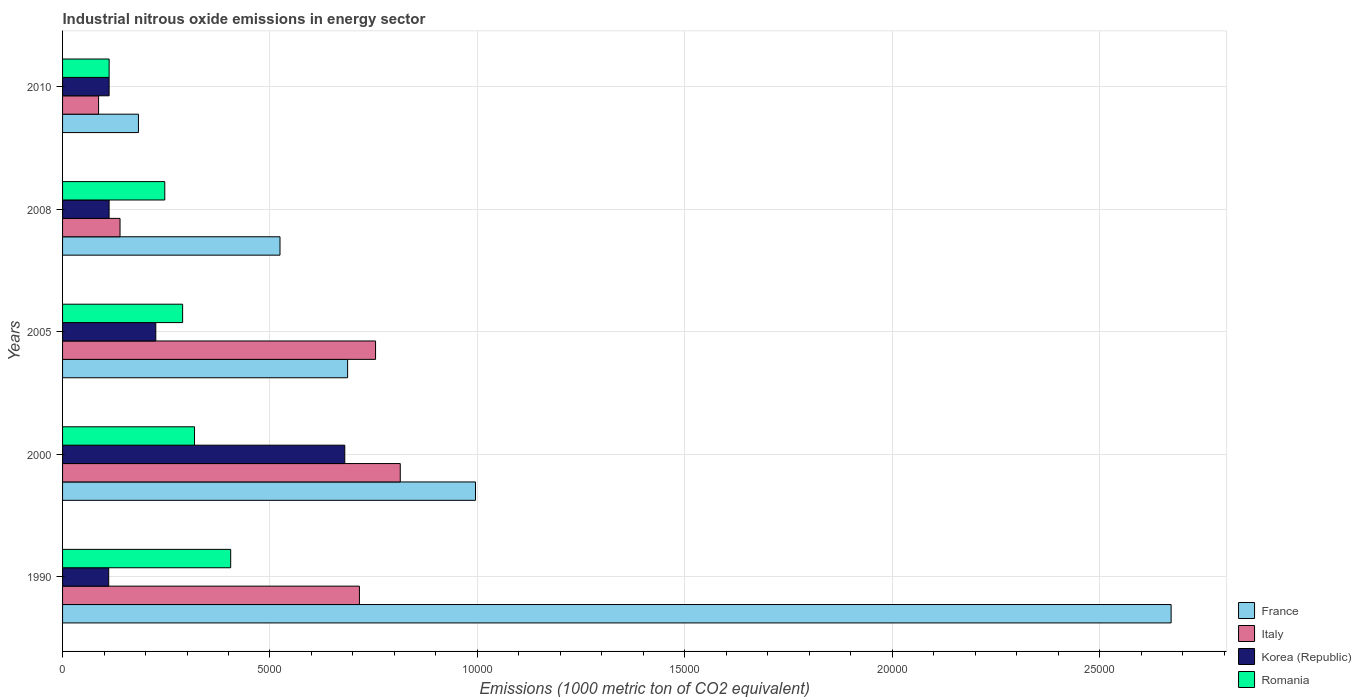How many different coloured bars are there?
Give a very brief answer. 4. Are the number of bars on each tick of the Y-axis equal?
Offer a terse response. Yes. What is the label of the 3rd group of bars from the top?
Your answer should be compact. 2005. What is the amount of industrial nitrous oxide emitted in Romania in 2005?
Provide a short and direct response. 2894.1. Across all years, what is the maximum amount of industrial nitrous oxide emitted in Romania?
Make the answer very short. 4052.7. Across all years, what is the minimum amount of industrial nitrous oxide emitted in Korea (Republic)?
Make the answer very short. 1112.3. In which year was the amount of industrial nitrous oxide emitted in France maximum?
Give a very brief answer. 1990. In which year was the amount of industrial nitrous oxide emitted in Romania minimum?
Your answer should be compact. 2010. What is the total amount of industrial nitrous oxide emitted in Romania in the graph?
Ensure brevity in your answer.  1.37e+04. What is the difference between the amount of industrial nitrous oxide emitted in France in 2005 and that in 2010?
Provide a succinct answer. 5042.8. What is the difference between the amount of industrial nitrous oxide emitted in Romania in 2010 and the amount of industrial nitrous oxide emitted in Italy in 2005?
Ensure brevity in your answer.  -6422.6. What is the average amount of industrial nitrous oxide emitted in France per year?
Provide a short and direct response. 1.01e+04. In the year 2010, what is the difference between the amount of industrial nitrous oxide emitted in Korea (Republic) and amount of industrial nitrous oxide emitted in France?
Offer a very short reply. -706.3. What is the ratio of the amount of industrial nitrous oxide emitted in Italy in 2000 to that in 2010?
Provide a short and direct response. 9.38. What is the difference between the highest and the second highest amount of industrial nitrous oxide emitted in Korea (Republic)?
Keep it short and to the point. 4555.5. What is the difference between the highest and the lowest amount of industrial nitrous oxide emitted in Korea (Republic)?
Ensure brevity in your answer.  5690.7. In how many years, is the amount of industrial nitrous oxide emitted in Italy greater than the average amount of industrial nitrous oxide emitted in Italy taken over all years?
Your answer should be compact. 3. Is it the case that in every year, the sum of the amount of industrial nitrous oxide emitted in Italy and amount of industrial nitrous oxide emitted in France is greater than the amount of industrial nitrous oxide emitted in Romania?
Provide a succinct answer. Yes. How many bars are there?
Give a very brief answer. 20. Are all the bars in the graph horizontal?
Make the answer very short. Yes. Does the graph contain any zero values?
Offer a terse response. No. Does the graph contain grids?
Provide a succinct answer. Yes. How are the legend labels stacked?
Your answer should be very brief. Vertical. What is the title of the graph?
Ensure brevity in your answer.  Industrial nitrous oxide emissions in energy sector. Does "Luxembourg" appear as one of the legend labels in the graph?
Make the answer very short. No. What is the label or title of the X-axis?
Keep it short and to the point. Emissions (1000 metric ton of CO2 equivalent). What is the Emissions (1000 metric ton of CO2 equivalent) in France in 1990?
Your answer should be compact. 2.67e+04. What is the Emissions (1000 metric ton of CO2 equivalent) in Italy in 1990?
Make the answer very short. 7155.8. What is the Emissions (1000 metric ton of CO2 equivalent) in Korea (Republic) in 1990?
Offer a very short reply. 1112.3. What is the Emissions (1000 metric ton of CO2 equivalent) of Romania in 1990?
Your answer should be very brief. 4052.7. What is the Emissions (1000 metric ton of CO2 equivalent) in France in 2000?
Offer a very short reply. 9953.8. What is the Emissions (1000 metric ton of CO2 equivalent) of Italy in 2000?
Keep it short and to the point. 8140.4. What is the Emissions (1000 metric ton of CO2 equivalent) in Korea (Republic) in 2000?
Keep it short and to the point. 6803. What is the Emissions (1000 metric ton of CO2 equivalent) in Romania in 2000?
Provide a short and direct response. 3180.9. What is the Emissions (1000 metric ton of CO2 equivalent) of France in 2005?
Your answer should be compact. 6871.6. What is the Emissions (1000 metric ton of CO2 equivalent) in Italy in 2005?
Keep it short and to the point. 7544.9. What is the Emissions (1000 metric ton of CO2 equivalent) in Korea (Republic) in 2005?
Provide a succinct answer. 2247.5. What is the Emissions (1000 metric ton of CO2 equivalent) in Romania in 2005?
Provide a succinct answer. 2894.1. What is the Emissions (1000 metric ton of CO2 equivalent) in France in 2008?
Make the answer very short. 5241.3. What is the Emissions (1000 metric ton of CO2 equivalent) of Italy in 2008?
Ensure brevity in your answer.  1385.2. What is the Emissions (1000 metric ton of CO2 equivalent) of Korea (Republic) in 2008?
Make the answer very short. 1121.9. What is the Emissions (1000 metric ton of CO2 equivalent) in Romania in 2008?
Your answer should be compact. 2463.8. What is the Emissions (1000 metric ton of CO2 equivalent) of France in 2010?
Keep it short and to the point. 1828.8. What is the Emissions (1000 metric ton of CO2 equivalent) in Italy in 2010?
Your answer should be compact. 868. What is the Emissions (1000 metric ton of CO2 equivalent) in Korea (Republic) in 2010?
Offer a terse response. 1122.5. What is the Emissions (1000 metric ton of CO2 equivalent) in Romania in 2010?
Offer a very short reply. 1122.3. Across all years, what is the maximum Emissions (1000 metric ton of CO2 equivalent) in France?
Make the answer very short. 2.67e+04. Across all years, what is the maximum Emissions (1000 metric ton of CO2 equivalent) in Italy?
Provide a succinct answer. 8140.4. Across all years, what is the maximum Emissions (1000 metric ton of CO2 equivalent) in Korea (Republic)?
Ensure brevity in your answer.  6803. Across all years, what is the maximum Emissions (1000 metric ton of CO2 equivalent) in Romania?
Offer a very short reply. 4052.7. Across all years, what is the minimum Emissions (1000 metric ton of CO2 equivalent) of France?
Make the answer very short. 1828.8. Across all years, what is the minimum Emissions (1000 metric ton of CO2 equivalent) of Italy?
Keep it short and to the point. 868. Across all years, what is the minimum Emissions (1000 metric ton of CO2 equivalent) of Korea (Republic)?
Ensure brevity in your answer.  1112.3. Across all years, what is the minimum Emissions (1000 metric ton of CO2 equivalent) in Romania?
Make the answer very short. 1122.3. What is the total Emissions (1000 metric ton of CO2 equivalent) of France in the graph?
Provide a short and direct response. 5.06e+04. What is the total Emissions (1000 metric ton of CO2 equivalent) of Italy in the graph?
Offer a very short reply. 2.51e+04. What is the total Emissions (1000 metric ton of CO2 equivalent) of Korea (Republic) in the graph?
Provide a short and direct response. 1.24e+04. What is the total Emissions (1000 metric ton of CO2 equivalent) of Romania in the graph?
Keep it short and to the point. 1.37e+04. What is the difference between the Emissions (1000 metric ton of CO2 equivalent) of France in 1990 and that in 2000?
Offer a very short reply. 1.68e+04. What is the difference between the Emissions (1000 metric ton of CO2 equivalent) in Italy in 1990 and that in 2000?
Keep it short and to the point. -984.6. What is the difference between the Emissions (1000 metric ton of CO2 equivalent) in Korea (Republic) in 1990 and that in 2000?
Provide a succinct answer. -5690.7. What is the difference between the Emissions (1000 metric ton of CO2 equivalent) of Romania in 1990 and that in 2000?
Keep it short and to the point. 871.8. What is the difference between the Emissions (1000 metric ton of CO2 equivalent) in France in 1990 and that in 2005?
Ensure brevity in your answer.  1.99e+04. What is the difference between the Emissions (1000 metric ton of CO2 equivalent) of Italy in 1990 and that in 2005?
Offer a very short reply. -389.1. What is the difference between the Emissions (1000 metric ton of CO2 equivalent) in Korea (Republic) in 1990 and that in 2005?
Keep it short and to the point. -1135.2. What is the difference between the Emissions (1000 metric ton of CO2 equivalent) in Romania in 1990 and that in 2005?
Make the answer very short. 1158.6. What is the difference between the Emissions (1000 metric ton of CO2 equivalent) in France in 1990 and that in 2008?
Give a very brief answer. 2.15e+04. What is the difference between the Emissions (1000 metric ton of CO2 equivalent) in Italy in 1990 and that in 2008?
Provide a short and direct response. 5770.6. What is the difference between the Emissions (1000 metric ton of CO2 equivalent) in Romania in 1990 and that in 2008?
Offer a terse response. 1588.9. What is the difference between the Emissions (1000 metric ton of CO2 equivalent) of France in 1990 and that in 2010?
Give a very brief answer. 2.49e+04. What is the difference between the Emissions (1000 metric ton of CO2 equivalent) of Italy in 1990 and that in 2010?
Your answer should be compact. 6287.8. What is the difference between the Emissions (1000 metric ton of CO2 equivalent) in Korea (Republic) in 1990 and that in 2010?
Your answer should be compact. -10.2. What is the difference between the Emissions (1000 metric ton of CO2 equivalent) of Romania in 1990 and that in 2010?
Your answer should be compact. 2930.4. What is the difference between the Emissions (1000 metric ton of CO2 equivalent) in France in 2000 and that in 2005?
Provide a succinct answer. 3082.2. What is the difference between the Emissions (1000 metric ton of CO2 equivalent) in Italy in 2000 and that in 2005?
Your response must be concise. 595.5. What is the difference between the Emissions (1000 metric ton of CO2 equivalent) in Korea (Republic) in 2000 and that in 2005?
Your response must be concise. 4555.5. What is the difference between the Emissions (1000 metric ton of CO2 equivalent) in Romania in 2000 and that in 2005?
Provide a short and direct response. 286.8. What is the difference between the Emissions (1000 metric ton of CO2 equivalent) in France in 2000 and that in 2008?
Give a very brief answer. 4712.5. What is the difference between the Emissions (1000 metric ton of CO2 equivalent) in Italy in 2000 and that in 2008?
Keep it short and to the point. 6755.2. What is the difference between the Emissions (1000 metric ton of CO2 equivalent) of Korea (Republic) in 2000 and that in 2008?
Your answer should be compact. 5681.1. What is the difference between the Emissions (1000 metric ton of CO2 equivalent) in Romania in 2000 and that in 2008?
Offer a very short reply. 717.1. What is the difference between the Emissions (1000 metric ton of CO2 equivalent) of France in 2000 and that in 2010?
Make the answer very short. 8125. What is the difference between the Emissions (1000 metric ton of CO2 equivalent) of Italy in 2000 and that in 2010?
Your response must be concise. 7272.4. What is the difference between the Emissions (1000 metric ton of CO2 equivalent) of Korea (Republic) in 2000 and that in 2010?
Ensure brevity in your answer.  5680.5. What is the difference between the Emissions (1000 metric ton of CO2 equivalent) in Romania in 2000 and that in 2010?
Provide a short and direct response. 2058.6. What is the difference between the Emissions (1000 metric ton of CO2 equivalent) in France in 2005 and that in 2008?
Provide a succinct answer. 1630.3. What is the difference between the Emissions (1000 metric ton of CO2 equivalent) in Italy in 2005 and that in 2008?
Offer a terse response. 6159.7. What is the difference between the Emissions (1000 metric ton of CO2 equivalent) in Korea (Republic) in 2005 and that in 2008?
Make the answer very short. 1125.6. What is the difference between the Emissions (1000 metric ton of CO2 equivalent) of Romania in 2005 and that in 2008?
Keep it short and to the point. 430.3. What is the difference between the Emissions (1000 metric ton of CO2 equivalent) of France in 2005 and that in 2010?
Provide a short and direct response. 5042.8. What is the difference between the Emissions (1000 metric ton of CO2 equivalent) of Italy in 2005 and that in 2010?
Keep it short and to the point. 6676.9. What is the difference between the Emissions (1000 metric ton of CO2 equivalent) in Korea (Republic) in 2005 and that in 2010?
Give a very brief answer. 1125. What is the difference between the Emissions (1000 metric ton of CO2 equivalent) in Romania in 2005 and that in 2010?
Your response must be concise. 1771.8. What is the difference between the Emissions (1000 metric ton of CO2 equivalent) of France in 2008 and that in 2010?
Give a very brief answer. 3412.5. What is the difference between the Emissions (1000 metric ton of CO2 equivalent) in Italy in 2008 and that in 2010?
Provide a succinct answer. 517.2. What is the difference between the Emissions (1000 metric ton of CO2 equivalent) of Romania in 2008 and that in 2010?
Ensure brevity in your answer.  1341.5. What is the difference between the Emissions (1000 metric ton of CO2 equivalent) in France in 1990 and the Emissions (1000 metric ton of CO2 equivalent) in Italy in 2000?
Ensure brevity in your answer.  1.86e+04. What is the difference between the Emissions (1000 metric ton of CO2 equivalent) in France in 1990 and the Emissions (1000 metric ton of CO2 equivalent) in Korea (Republic) in 2000?
Your response must be concise. 1.99e+04. What is the difference between the Emissions (1000 metric ton of CO2 equivalent) in France in 1990 and the Emissions (1000 metric ton of CO2 equivalent) in Romania in 2000?
Keep it short and to the point. 2.35e+04. What is the difference between the Emissions (1000 metric ton of CO2 equivalent) of Italy in 1990 and the Emissions (1000 metric ton of CO2 equivalent) of Korea (Republic) in 2000?
Provide a short and direct response. 352.8. What is the difference between the Emissions (1000 metric ton of CO2 equivalent) of Italy in 1990 and the Emissions (1000 metric ton of CO2 equivalent) of Romania in 2000?
Keep it short and to the point. 3974.9. What is the difference between the Emissions (1000 metric ton of CO2 equivalent) of Korea (Republic) in 1990 and the Emissions (1000 metric ton of CO2 equivalent) of Romania in 2000?
Ensure brevity in your answer.  -2068.6. What is the difference between the Emissions (1000 metric ton of CO2 equivalent) of France in 1990 and the Emissions (1000 metric ton of CO2 equivalent) of Italy in 2005?
Give a very brief answer. 1.92e+04. What is the difference between the Emissions (1000 metric ton of CO2 equivalent) in France in 1990 and the Emissions (1000 metric ton of CO2 equivalent) in Korea (Republic) in 2005?
Offer a terse response. 2.45e+04. What is the difference between the Emissions (1000 metric ton of CO2 equivalent) in France in 1990 and the Emissions (1000 metric ton of CO2 equivalent) in Romania in 2005?
Keep it short and to the point. 2.38e+04. What is the difference between the Emissions (1000 metric ton of CO2 equivalent) in Italy in 1990 and the Emissions (1000 metric ton of CO2 equivalent) in Korea (Republic) in 2005?
Offer a very short reply. 4908.3. What is the difference between the Emissions (1000 metric ton of CO2 equivalent) in Italy in 1990 and the Emissions (1000 metric ton of CO2 equivalent) in Romania in 2005?
Offer a very short reply. 4261.7. What is the difference between the Emissions (1000 metric ton of CO2 equivalent) in Korea (Republic) in 1990 and the Emissions (1000 metric ton of CO2 equivalent) in Romania in 2005?
Your response must be concise. -1781.8. What is the difference between the Emissions (1000 metric ton of CO2 equivalent) of France in 1990 and the Emissions (1000 metric ton of CO2 equivalent) of Italy in 2008?
Ensure brevity in your answer.  2.53e+04. What is the difference between the Emissions (1000 metric ton of CO2 equivalent) of France in 1990 and the Emissions (1000 metric ton of CO2 equivalent) of Korea (Republic) in 2008?
Offer a terse response. 2.56e+04. What is the difference between the Emissions (1000 metric ton of CO2 equivalent) of France in 1990 and the Emissions (1000 metric ton of CO2 equivalent) of Romania in 2008?
Make the answer very short. 2.43e+04. What is the difference between the Emissions (1000 metric ton of CO2 equivalent) in Italy in 1990 and the Emissions (1000 metric ton of CO2 equivalent) in Korea (Republic) in 2008?
Offer a very short reply. 6033.9. What is the difference between the Emissions (1000 metric ton of CO2 equivalent) in Italy in 1990 and the Emissions (1000 metric ton of CO2 equivalent) in Romania in 2008?
Your answer should be compact. 4692. What is the difference between the Emissions (1000 metric ton of CO2 equivalent) of Korea (Republic) in 1990 and the Emissions (1000 metric ton of CO2 equivalent) of Romania in 2008?
Your answer should be compact. -1351.5. What is the difference between the Emissions (1000 metric ton of CO2 equivalent) in France in 1990 and the Emissions (1000 metric ton of CO2 equivalent) in Italy in 2010?
Your response must be concise. 2.59e+04. What is the difference between the Emissions (1000 metric ton of CO2 equivalent) of France in 1990 and the Emissions (1000 metric ton of CO2 equivalent) of Korea (Republic) in 2010?
Provide a succinct answer. 2.56e+04. What is the difference between the Emissions (1000 metric ton of CO2 equivalent) of France in 1990 and the Emissions (1000 metric ton of CO2 equivalent) of Romania in 2010?
Ensure brevity in your answer.  2.56e+04. What is the difference between the Emissions (1000 metric ton of CO2 equivalent) of Italy in 1990 and the Emissions (1000 metric ton of CO2 equivalent) of Korea (Republic) in 2010?
Make the answer very short. 6033.3. What is the difference between the Emissions (1000 metric ton of CO2 equivalent) of Italy in 1990 and the Emissions (1000 metric ton of CO2 equivalent) of Romania in 2010?
Your answer should be very brief. 6033.5. What is the difference between the Emissions (1000 metric ton of CO2 equivalent) in France in 2000 and the Emissions (1000 metric ton of CO2 equivalent) in Italy in 2005?
Offer a terse response. 2408.9. What is the difference between the Emissions (1000 metric ton of CO2 equivalent) of France in 2000 and the Emissions (1000 metric ton of CO2 equivalent) of Korea (Republic) in 2005?
Give a very brief answer. 7706.3. What is the difference between the Emissions (1000 metric ton of CO2 equivalent) of France in 2000 and the Emissions (1000 metric ton of CO2 equivalent) of Romania in 2005?
Ensure brevity in your answer.  7059.7. What is the difference between the Emissions (1000 metric ton of CO2 equivalent) of Italy in 2000 and the Emissions (1000 metric ton of CO2 equivalent) of Korea (Republic) in 2005?
Offer a terse response. 5892.9. What is the difference between the Emissions (1000 metric ton of CO2 equivalent) of Italy in 2000 and the Emissions (1000 metric ton of CO2 equivalent) of Romania in 2005?
Your answer should be very brief. 5246.3. What is the difference between the Emissions (1000 metric ton of CO2 equivalent) in Korea (Republic) in 2000 and the Emissions (1000 metric ton of CO2 equivalent) in Romania in 2005?
Your response must be concise. 3908.9. What is the difference between the Emissions (1000 metric ton of CO2 equivalent) in France in 2000 and the Emissions (1000 metric ton of CO2 equivalent) in Italy in 2008?
Make the answer very short. 8568.6. What is the difference between the Emissions (1000 metric ton of CO2 equivalent) in France in 2000 and the Emissions (1000 metric ton of CO2 equivalent) in Korea (Republic) in 2008?
Offer a terse response. 8831.9. What is the difference between the Emissions (1000 metric ton of CO2 equivalent) of France in 2000 and the Emissions (1000 metric ton of CO2 equivalent) of Romania in 2008?
Offer a terse response. 7490. What is the difference between the Emissions (1000 metric ton of CO2 equivalent) of Italy in 2000 and the Emissions (1000 metric ton of CO2 equivalent) of Korea (Republic) in 2008?
Your answer should be compact. 7018.5. What is the difference between the Emissions (1000 metric ton of CO2 equivalent) in Italy in 2000 and the Emissions (1000 metric ton of CO2 equivalent) in Romania in 2008?
Your response must be concise. 5676.6. What is the difference between the Emissions (1000 metric ton of CO2 equivalent) in Korea (Republic) in 2000 and the Emissions (1000 metric ton of CO2 equivalent) in Romania in 2008?
Give a very brief answer. 4339.2. What is the difference between the Emissions (1000 metric ton of CO2 equivalent) of France in 2000 and the Emissions (1000 metric ton of CO2 equivalent) of Italy in 2010?
Your answer should be compact. 9085.8. What is the difference between the Emissions (1000 metric ton of CO2 equivalent) in France in 2000 and the Emissions (1000 metric ton of CO2 equivalent) in Korea (Republic) in 2010?
Ensure brevity in your answer.  8831.3. What is the difference between the Emissions (1000 metric ton of CO2 equivalent) of France in 2000 and the Emissions (1000 metric ton of CO2 equivalent) of Romania in 2010?
Keep it short and to the point. 8831.5. What is the difference between the Emissions (1000 metric ton of CO2 equivalent) of Italy in 2000 and the Emissions (1000 metric ton of CO2 equivalent) of Korea (Republic) in 2010?
Your response must be concise. 7017.9. What is the difference between the Emissions (1000 metric ton of CO2 equivalent) of Italy in 2000 and the Emissions (1000 metric ton of CO2 equivalent) of Romania in 2010?
Provide a short and direct response. 7018.1. What is the difference between the Emissions (1000 metric ton of CO2 equivalent) of Korea (Republic) in 2000 and the Emissions (1000 metric ton of CO2 equivalent) of Romania in 2010?
Provide a succinct answer. 5680.7. What is the difference between the Emissions (1000 metric ton of CO2 equivalent) of France in 2005 and the Emissions (1000 metric ton of CO2 equivalent) of Italy in 2008?
Offer a very short reply. 5486.4. What is the difference between the Emissions (1000 metric ton of CO2 equivalent) in France in 2005 and the Emissions (1000 metric ton of CO2 equivalent) in Korea (Republic) in 2008?
Ensure brevity in your answer.  5749.7. What is the difference between the Emissions (1000 metric ton of CO2 equivalent) in France in 2005 and the Emissions (1000 metric ton of CO2 equivalent) in Romania in 2008?
Keep it short and to the point. 4407.8. What is the difference between the Emissions (1000 metric ton of CO2 equivalent) in Italy in 2005 and the Emissions (1000 metric ton of CO2 equivalent) in Korea (Republic) in 2008?
Keep it short and to the point. 6423. What is the difference between the Emissions (1000 metric ton of CO2 equivalent) in Italy in 2005 and the Emissions (1000 metric ton of CO2 equivalent) in Romania in 2008?
Your answer should be very brief. 5081.1. What is the difference between the Emissions (1000 metric ton of CO2 equivalent) of Korea (Republic) in 2005 and the Emissions (1000 metric ton of CO2 equivalent) of Romania in 2008?
Give a very brief answer. -216.3. What is the difference between the Emissions (1000 metric ton of CO2 equivalent) of France in 2005 and the Emissions (1000 metric ton of CO2 equivalent) of Italy in 2010?
Provide a succinct answer. 6003.6. What is the difference between the Emissions (1000 metric ton of CO2 equivalent) of France in 2005 and the Emissions (1000 metric ton of CO2 equivalent) of Korea (Republic) in 2010?
Provide a short and direct response. 5749.1. What is the difference between the Emissions (1000 metric ton of CO2 equivalent) of France in 2005 and the Emissions (1000 metric ton of CO2 equivalent) of Romania in 2010?
Your response must be concise. 5749.3. What is the difference between the Emissions (1000 metric ton of CO2 equivalent) in Italy in 2005 and the Emissions (1000 metric ton of CO2 equivalent) in Korea (Republic) in 2010?
Ensure brevity in your answer.  6422.4. What is the difference between the Emissions (1000 metric ton of CO2 equivalent) in Italy in 2005 and the Emissions (1000 metric ton of CO2 equivalent) in Romania in 2010?
Your answer should be very brief. 6422.6. What is the difference between the Emissions (1000 metric ton of CO2 equivalent) in Korea (Republic) in 2005 and the Emissions (1000 metric ton of CO2 equivalent) in Romania in 2010?
Your answer should be compact. 1125.2. What is the difference between the Emissions (1000 metric ton of CO2 equivalent) in France in 2008 and the Emissions (1000 metric ton of CO2 equivalent) in Italy in 2010?
Provide a succinct answer. 4373.3. What is the difference between the Emissions (1000 metric ton of CO2 equivalent) of France in 2008 and the Emissions (1000 metric ton of CO2 equivalent) of Korea (Republic) in 2010?
Make the answer very short. 4118.8. What is the difference between the Emissions (1000 metric ton of CO2 equivalent) of France in 2008 and the Emissions (1000 metric ton of CO2 equivalent) of Romania in 2010?
Provide a succinct answer. 4119. What is the difference between the Emissions (1000 metric ton of CO2 equivalent) of Italy in 2008 and the Emissions (1000 metric ton of CO2 equivalent) of Korea (Republic) in 2010?
Your answer should be very brief. 262.7. What is the difference between the Emissions (1000 metric ton of CO2 equivalent) of Italy in 2008 and the Emissions (1000 metric ton of CO2 equivalent) of Romania in 2010?
Ensure brevity in your answer.  262.9. What is the difference between the Emissions (1000 metric ton of CO2 equivalent) in Korea (Republic) in 2008 and the Emissions (1000 metric ton of CO2 equivalent) in Romania in 2010?
Keep it short and to the point. -0.4. What is the average Emissions (1000 metric ton of CO2 equivalent) in France per year?
Make the answer very short. 1.01e+04. What is the average Emissions (1000 metric ton of CO2 equivalent) of Italy per year?
Give a very brief answer. 5018.86. What is the average Emissions (1000 metric ton of CO2 equivalent) in Korea (Republic) per year?
Give a very brief answer. 2481.44. What is the average Emissions (1000 metric ton of CO2 equivalent) of Romania per year?
Provide a succinct answer. 2742.76. In the year 1990, what is the difference between the Emissions (1000 metric ton of CO2 equivalent) in France and Emissions (1000 metric ton of CO2 equivalent) in Italy?
Offer a very short reply. 1.96e+04. In the year 1990, what is the difference between the Emissions (1000 metric ton of CO2 equivalent) of France and Emissions (1000 metric ton of CO2 equivalent) of Korea (Republic)?
Provide a short and direct response. 2.56e+04. In the year 1990, what is the difference between the Emissions (1000 metric ton of CO2 equivalent) of France and Emissions (1000 metric ton of CO2 equivalent) of Romania?
Your answer should be very brief. 2.27e+04. In the year 1990, what is the difference between the Emissions (1000 metric ton of CO2 equivalent) in Italy and Emissions (1000 metric ton of CO2 equivalent) in Korea (Republic)?
Offer a terse response. 6043.5. In the year 1990, what is the difference between the Emissions (1000 metric ton of CO2 equivalent) in Italy and Emissions (1000 metric ton of CO2 equivalent) in Romania?
Make the answer very short. 3103.1. In the year 1990, what is the difference between the Emissions (1000 metric ton of CO2 equivalent) of Korea (Republic) and Emissions (1000 metric ton of CO2 equivalent) of Romania?
Provide a succinct answer. -2940.4. In the year 2000, what is the difference between the Emissions (1000 metric ton of CO2 equivalent) of France and Emissions (1000 metric ton of CO2 equivalent) of Italy?
Keep it short and to the point. 1813.4. In the year 2000, what is the difference between the Emissions (1000 metric ton of CO2 equivalent) of France and Emissions (1000 metric ton of CO2 equivalent) of Korea (Republic)?
Keep it short and to the point. 3150.8. In the year 2000, what is the difference between the Emissions (1000 metric ton of CO2 equivalent) of France and Emissions (1000 metric ton of CO2 equivalent) of Romania?
Provide a succinct answer. 6772.9. In the year 2000, what is the difference between the Emissions (1000 metric ton of CO2 equivalent) of Italy and Emissions (1000 metric ton of CO2 equivalent) of Korea (Republic)?
Offer a terse response. 1337.4. In the year 2000, what is the difference between the Emissions (1000 metric ton of CO2 equivalent) in Italy and Emissions (1000 metric ton of CO2 equivalent) in Romania?
Offer a very short reply. 4959.5. In the year 2000, what is the difference between the Emissions (1000 metric ton of CO2 equivalent) in Korea (Republic) and Emissions (1000 metric ton of CO2 equivalent) in Romania?
Offer a terse response. 3622.1. In the year 2005, what is the difference between the Emissions (1000 metric ton of CO2 equivalent) in France and Emissions (1000 metric ton of CO2 equivalent) in Italy?
Ensure brevity in your answer.  -673.3. In the year 2005, what is the difference between the Emissions (1000 metric ton of CO2 equivalent) in France and Emissions (1000 metric ton of CO2 equivalent) in Korea (Republic)?
Your response must be concise. 4624.1. In the year 2005, what is the difference between the Emissions (1000 metric ton of CO2 equivalent) in France and Emissions (1000 metric ton of CO2 equivalent) in Romania?
Provide a short and direct response. 3977.5. In the year 2005, what is the difference between the Emissions (1000 metric ton of CO2 equivalent) of Italy and Emissions (1000 metric ton of CO2 equivalent) of Korea (Republic)?
Your response must be concise. 5297.4. In the year 2005, what is the difference between the Emissions (1000 metric ton of CO2 equivalent) in Italy and Emissions (1000 metric ton of CO2 equivalent) in Romania?
Your answer should be very brief. 4650.8. In the year 2005, what is the difference between the Emissions (1000 metric ton of CO2 equivalent) of Korea (Republic) and Emissions (1000 metric ton of CO2 equivalent) of Romania?
Offer a terse response. -646.6. In the year 2008, what is the difference between the Emissions (1000 metric ton of CO2 equivalent) in France and Emissions (1000 metric ton of CO2 equivalent) in Italy?
Your answer should be compact. 3856.1. In the year 2008, what is the difference between the Emissions (1000 metric ton of CO2 equivalent) in France and Emissions (1000 metric ton of CO2 equivalent) in Korea (Republic)?
Provide a short and direct response. 4119.4. In the year 2008, what is the difference between the Emissions (1000 metric ton of CO2 equivalent) in France and Emissions (1000 metric ton of CO2 equivalent) in Romania?
Your answer should be compact. 2777.5. In the year 2008, what is the difference between the Emissions (1000 metric ton of CO2 equivalent) of Italy and Emissions (1000 metric ton of CO2 equivalent) of Korea (Republic)?
Your response must be concise. 263.3. In the year 2008, what is the difference between the Emissions (1000 metric ton of CO2 equivalent) in Italy and Emissions (1000 metric ton of CO2 equivalent) in Romania?
Give a very brief answer. -1078.6. In the year 2008, what is the difference between the Emissions (1000 metric ton of CO2 equivalent) in Korea (Republic) and Emissions (1000 metric ton of CO2 equivalent) in Romania?
Give a very brief answer. -1341.9. In the year 2010, what is the difference between the Emissions (1000 metric ton of CO2 equivalent) of France and Emissions (1000 metric ton of CO2 equivalent) of Italy?
Offer a terse response. 960.8. In the year 2010, what is the difference between the Emissions (1000 metric ton of CO2 equivalent) of France and Emissions (1000 metric ton of CO2 equivalent) of Korea (Republic)?
Your answer should be very brief. 706.3. In the year 2010, what is the difference between the Emissions (1000 metric ton of CO2 equivalent) of France and Emissions (1000 metric ton of CO2 equivalent) of Romania?
Your response must be concise. 706.5. In the year 2010, what is the difference between the Emissions (1000 metric ton of CO2 equivalent) of Italy and Emissions (1000 metric ton of CO2 equivalent) of Korea (Republic)?
Your response must be concise. -254.5. In the year 2010, what is the difference between the Emissions (1000 metric ton of CO2 equivalent) of Italy and Emissions (1000 metric ton of CO2 equivalent) of Romania?
Provide a short and direct response. -254.3. What is the ratio of the Emissions (1000 metric ton of CO2 equivalent) in France in 1990 to that in 2000?
Provide a succinct answer. 2.68. What is the ratio of the Emissions (1000 metric ton of CO2 equivalent) in Italy in 1990 to that in 2000?
Offer a terse response. 0.88. What is the ratio of the Emissions (1000 metric ton of CO2 equivalent) of Korea (Republic) in 1990 to that in 2000?
Offer a very short reply. 0.16. What is the ratio of the Emissions (1000 metric ton of CO2 equivalent) in Romania in 1990 to that in 2000?
Your answer should be very brief. 1.27. What is the ratio of the Emissions (1000 metric ton of CO2 equivalent) of France in 1990 to that in 2005?
Your answer should be compact. 3.89. What is the ratio of the Emissions (1000 metric ton of CO2 equivalent) in Italy in 1990 to that in 2005?
Your answer should be compact. 0.95. What is the ratio of the Emissions (1000 metric ton of CO2 equivalent) of Korea (Republic) in 1990 to that in 2005?
Your response must be concise. 0.49. What is the ratio of the Emissions (1000 metric ton of CO2 equivalent) of Romania in 1990 to that in 2005?
Your answer should be very brief. 1.4. What is the ratio of the Emissions (1000 metric ton of CO2 equivalent) in France in 1990 to that in 2008?
Provide a succinct answer. 5.1. What is the ratio of the Emissions (1000 metric ton of CO2 equivalent) in Italy in 1990 to that in 2008?
Make the answer very short. 5.17. What is the ratio of the Emissions (1000 metric ton of CO2 equivalent) in Romania in 1990 to that in 2008?
Provide a short and direct response. 1.64. What is the ratio of the Emissions (1000 metric ton of CO2 equivalent) of France in 1990 to that in 2010?
Offer a very short reply. 14.61. What is the ratio of the Emissions (1000 metric ton of CO2 equivalent) of Italy in 1990 to that in 2010?
Provide a succinct answer. 8.24. What is the ratio of the Emissions (1000 metric ton of CO2 equivalent) in Korea (Republic) in 1990 to that in 2010?
Your answer should be very brief. 0.99. What is the ratio of the Emissions (1000 metric ton of CO2 equivalent) of Romania in 1990 to that in 2010?
Offer a terse response. 3.61. What is the ratio of the Emissions (1000 metric ton of CO2 equivalent) in France in 2000 to that in 2005?
Your response must be concise. 1.45. What is the ratio of the Emissions (1000 metric ton of CO2 equivalent) in Italy in 2000 to that in 2005?
Give a very brief answer. 1.08. What is the ratio of the Emissions (1000 metric ton of CO2 equivalent) in Korea (Republic) in 2000 to that in 2005?
Provide a succinct answer. 3.03. What is the ratio of the Emissions (1000 metric ton of CO2 equivalent) in Romania in 2000 to that in 2005?
Make the answer very short. 1.1. What is the ratio of the Emissions (1000 metric ton of CO2 equivalent) in France in 2000 to that in 2008?
Ensure brevity in your answer.  1.9. What is the ratio of the Emissions (1000 metric ton of CO2 equivalent) of Italy in 2000 to that in 2008?
Provide a succinct answer. 5.88. What is the ratio of the Emissions (1000 metric ton of CO2 equivalent) in Korea (Republic) in 2000 to that in 2008?
Your answer should be compact. 6.06. What is the ratio of the Emissions (1000 metric ton of CO2 equivalent) of Romania in 2000 to that in 2008?
Keep it short and to the point. 1.29. What is the ratio of the Emissions (1000 metric ton of CO2 equivalent) of France in 2000 to that in 2010?
Your response must be concise. 5.44. What is the ratio of the Emissions (1000 metric ton of CO2 equivalent) in Italy in 2000 to that in 2010?
Offer a very short reply. 9.38. What is the ratio of the Emissions (1000 metric ton of CO2 equivalent) of Korea (Republic) in 2000 to that in 2010?
Ensure brevity in your answer.  6.06. What is the ratio of the Emissions (1000 metric ton of CO2 equivalent) of Romania in 2000 to that in 2010?
Provide a short and direct response. 2.83. What is the ratio of the Emissions (1000 metric ton of CO2 equivalent) in France in 2005 to that in 2008?
Provide a succinct answer. 1.31. What is the ratio of the Emissions (1000 metric ton of CO2 equivalent) in Italy in 2005 to that in 2008?
Make the answer very short. 5.45. What is the ratio of the Emissions (1000 metric ton of CO2 equivalent) of Korea (Republic) in 2005 to that in 2008?
Provide a short and direct response. 2. What is the ratio of the Emissions (1000 metric ton of CO2 equivalent) in Romania in 2005 to that in 2008?
Your answer should be compact. 1.17. What is the ratio of the Emissions (1000 metric ton of CO2 equivalent) in France in 2005 to that in 2010?
Ensure brevity in your answer.  3.76. What is the ratio of the Emissions (1000 metric ton of CO2 equivalent) of Italy in 2005 to that in 2010?
Provide a succinct answer. 8.69. What is the ratio of the Emissions (1000 metric ton of CO2 equivalent) of Korea (Republic) in 2005 to that in 2010?
Your answer should be very brief. 2. What is the ratio of the Emissions (1000 metric ton of CO2 equivalent) in Romania in 2005 to that in 2010?
Provide a short and direct response. 2.58. What is the ratio of the Emissions (1000 metric ton of CO2 equivalent) in France in 2008 to that in 2010?
Provide a short and direct response. 2.87. What is the ratio of the Emissions (1000 metric ton of CO2 equivalent) in Italy in 2008 to that in 2010?
Make the answer very short. 1.6. What is the ratio of the Emissions (1000 metric ton of CO2 equivalent) in Romania in 2008 to that in 2010?
Offer a very short reply. 2.2. What is the difference between the highest and the second highest Emissions (1000 metric ton of CO2 equivalent) of France?
Your answer should be very brief. 1.68e+04. What is the difference between the highest and the second highest Emissions (1000 metric ton of CO2 equivalent) of Italy?
Provide a succinct answer. 595.5. What is the difference between the highest and the second highest Emissions (1000 metric ton of CO2 equivalent) in Korea (Republic)?
Make the answer very short. 4555.5. What is the difference between the highest and the second highest Emissions (1000 metric ton of CO2 equivalent) in Romania?
Provide a succinct answer. 871.8. What is the difference between the highest and the lowest Emissions (1000 metric ton of CO2 equivalent) of France?
Ensure brevity in your answer.  2.49e+04. What is the difference between the highest and the lowest Emissions (1000 metric ton of CO2 equivalent) of Italy?
Offer a very short reply. 7272.4. What is the difference between the highest and the lowest Emissions (1000 metric ton of CO2 equivalent) in Korea (Republic)?
Offer a very short reply. 5690.7. What is the difference between the highest and the lowest Emissions (1000 metric ton of CO2 equivalent) in Romania?
Your answer should be compact. 2930.4. 